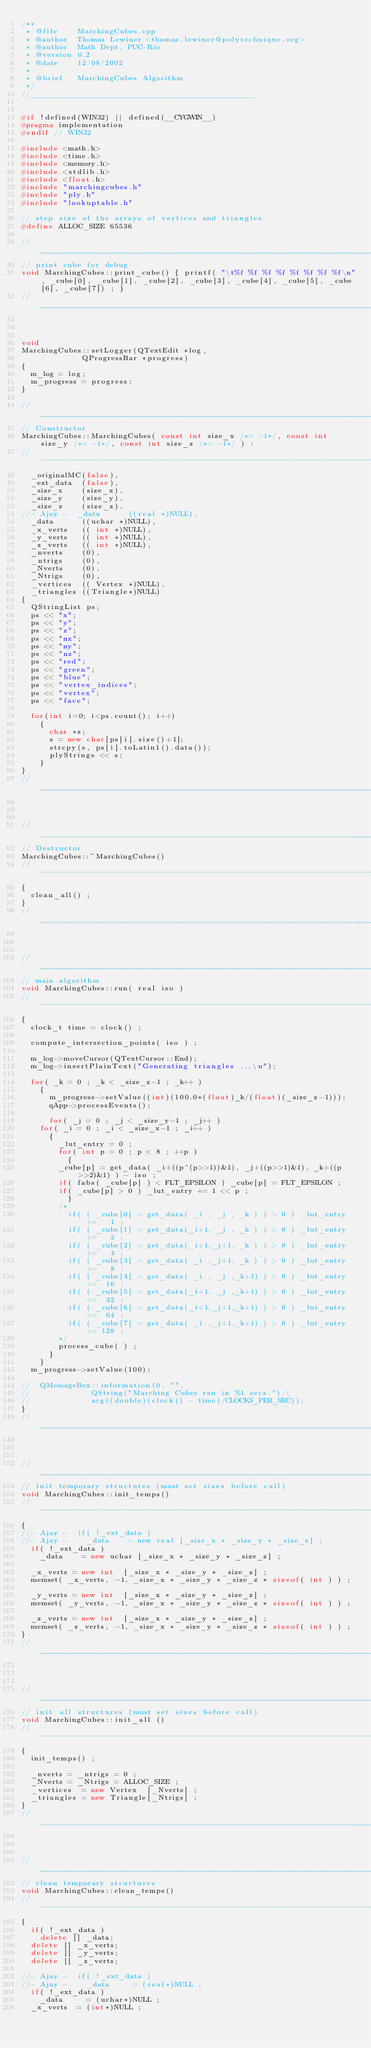<code> <loc_0><loc_0><loc_500><loc_500><_C++_>/**
 * @file    MarchingCubes.cpp
 * @author  Thomas Lewiner <thomas.lewiner@polytechnique.org>
 * @author  Math Dept, PUC-Rio
 * @version 0.2
 * @date    12/08/2002
 *
 * @brief   MarchingCubes Algorithm
 */
//________________________________________________


#if !defined(WIN32) || defined(__CYGWIN__)
#pragma implementation
#endif // WIN32

#include <math.h>
#include <time.h>
#include <memory.h>
#include <stdlib.h>
#include <float.h>
#include "marchingcubes.h"
#include "ply.h"
#include "lookuptable.h"

// step size of the arrays of vertices and triangles
#define ALLOC_SIZE 65536

//_____________________________________________________________________________
// print cube for debug
void MarchingCubes::print_cube() { printf( "\t%f %f %f %f %f %f %f %f\n", _cube[0], _cube[1], _cube[2], _cube[3], _cube[4], _cube[5], _cube[6], _cube[7]) ; }
//_____________________________________________________________________________



void
MarchingCubes::setLogger(QTextEdit *log,
			 QProgressBar *progress)
{
  m_log = log;
  m_progress = progress;
}

//_____________________________________________________________________________
// Constructor
MarchingCubes::MarchingCubes( const int size_x /*= -1*/, const int size_y /*= -1*/, const int size_z /*= -1*/ ) :
//-----------------------------------------------------------------------------
  _originalMC(false),
  _ext_data  (false),
  _size_x    (size_x),
  _size_y    (size_y),
  _size_z    (size_z),
//- Ajay -  _data      ((real *)NULL),
  _data      ((uchar *)NULL),
  _x_verts   (( int *)NULL),
  _y_verts   (( int *)NULL),
  _z_verts   (( int *)NULL),
  _nverts    (0),
  _ntrigs    (0),
  _Nverts    (0),
  _Ntrigs    (0),
  _vertices  (( Vertex *)NULL),
  _triangles ((Triangle*)NULL)
{
  QStringList ps;
  ps << "x";
  ps << "y";
  ps << "z";
  ps << "nx";
  ps << "ny";
  ps << "nz";
  ps << "red";
  ps << "green";
  ps << "blue";
  ps << "vertex_indices";
  ps << "vertex";
  ps << "face";

  for(int i=0; i<ps.count(); i++)
    {
      char *s;
      s = new char[ps[i].size()+1];
      strcpy(s, ps[i].toLatin1().data());
      plyStrings << s;
    }
}
//_____________________________________________________________________________



//_____________________________________________________________________________
// Destructor
MarchingCubes::~MarchingCubes()
//-----------------------------------------------------------------------------
{
  clean_all() ;
}
//_____________________________________________________________________________



//_____________________________________________________________________________
// main algorithm
void MarchingCubes::run( real iso )
//-----------------------------------------------------------------------------
{
  clock_t time = clock() ;

  compute_intersection_points( iso ) ;

  m_log->moveCursor(QTextCursor::End);
  m_log->insertPlainText("Generating triangles ...\n");

  for( _k = 0 ; _k < _size_z-1 ; _k++ )
    {
      m_progress->setValue((int)(100.0*(float)_k/(float)(_size_z-1)));
      qApp->processEvents();

      for( _j = 0 ; _j < _size_y-1 ; _j++ )
	for( _i = 0 ; _i < _size_x-1 ; _i++ )
	  {
	    _lut_entry = 0 ;
	    for( int p = 0 ; p < 8 ; ++p )
	      {
		_cube[p] = get_data( _i+((p^(p>>1))&1), _j+((p>>1)&1), _k+((p>>2)&1) ) - iso ;
		if( fabs( _cube[p] ) < FLT_EPSILON ) _cube[p] = FLT_EPSILON ;
		if( _cube[p] > 0 ) _lut_entry += 1 << p ;
	      }
	    /*
	      if( ( _cube[0] = get_data( _i , _j , _k ) ) > 0 ) _lut_entry +=   1 ;
	      if( ( _cube[1] = get_data(_i+1, _j , _k ) ) > 0 ) _lut_entry +=   2 ;
	      if( ( _cube[2] = get_data(_i+1,_j+1, _k ) ) > 0 ) _lut_entry +=   4 ;
	      if( ( _cube[3] = get_data( _i ,_j+1, _k ) ) > 0 ) _lut_entry +=   8 ;
	      if( ( _cube[4] = get_data( _i , _j ,_k+1) ) > 0 ) _lut_entry +=  16 ;
	      if( ( _cube[5] = get_data(_i+1, _j ,_k+1) ) > 0 ) _lut_entry +=  32 ;
	      if( ( _cube[6] = get_data(_i+1,_j+1,_k+1) ) > 0 ) _lut_entry +=  64 ;
	      if( ( _cube[7] = get_data( _i ,_j+1,_k+1) ) > 0 ) _lut_entry += 128 ;
	    */
	    process_cube( ) ;
	  }
    }
  m_progress->setValue(100);

//  QMessageBox::information(0, "", 
//			   QString("Marching Cubes ran in %1 secs.").\
//			   arg((double)(clock() - time)/CLOCKS_PER_SEC));
}
//_____________________________________________________________________________



//_____________________________________________________________________________
// init temporary structures (must set sizes before call)
void MarchingCubes::init_temps()
//-----------------------------------------------------------------------------
{
//- Ajay -  if( !_ext_data )
//- Ajay -    _data    = new real [_size_x * _size_y * _size_z] ;
  if( !_ext_data )
    _data    = new uchar [_size_x * _size_y * _size_z] ;

  _x_verts = new int  [_size_x * _size_y * _size_z] ;
  memset( _x_verts, -1, _size_x * _size_y * _size_z * sizeof( int ) ) ;

  _y_verts = new int  [_size_x * _size_y * _size_z] ;
  memset( _y_verts, -1, _size_x * _size_y * _size_z * sizeof( int ) ) ;

  _z_verts = new int  [_size_x * _size_y * _size_z] ;
  memset( _z_verts, -1, _size_x * _size_y * _size_z * sizeof( int ) ) ;
}
//_____________________________________________________________________________



//_____________________________________________________________________________
// init all structures (must set sizes before call)
void MarchingCubes::init_all ()
//-----------------------------------------------------------------------------
{
  init_temps() ;

  _nverts = _ntrigs = 0 ;
  _Nverts = _Ntrigs = ALLOC_SIZE ;
  _vertices  = new Vertex  [_Nverts] ;
  _triangles = new Triangle[_Ntrigs] ;
}
//_____________________________________________________________________________



//_____________________________________________________________________________
// clean temporary structures
void MarchingCubes::clean_temps()
//-----------------------------------------------------------------------------
{
  if( !_ext_data )
    delete [] _data;
  delete [] _x_verts;
  delete [] _y_verts;
  delete [] _z_verts;

//- Ajay -  if( !_ext_data )
//- Ajay -    _data     = (real*)NULL ;
  if( !_ext_data )
    _data     = (uchar*)NULL ;
  _x_verts  = (int*)NULL ;</code> 